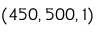Convert formula to latex. <formula><loc_0><loc_0><loc_500><loc_500>( 4 5 0 , 5 0 0 , 1 )</formula> 